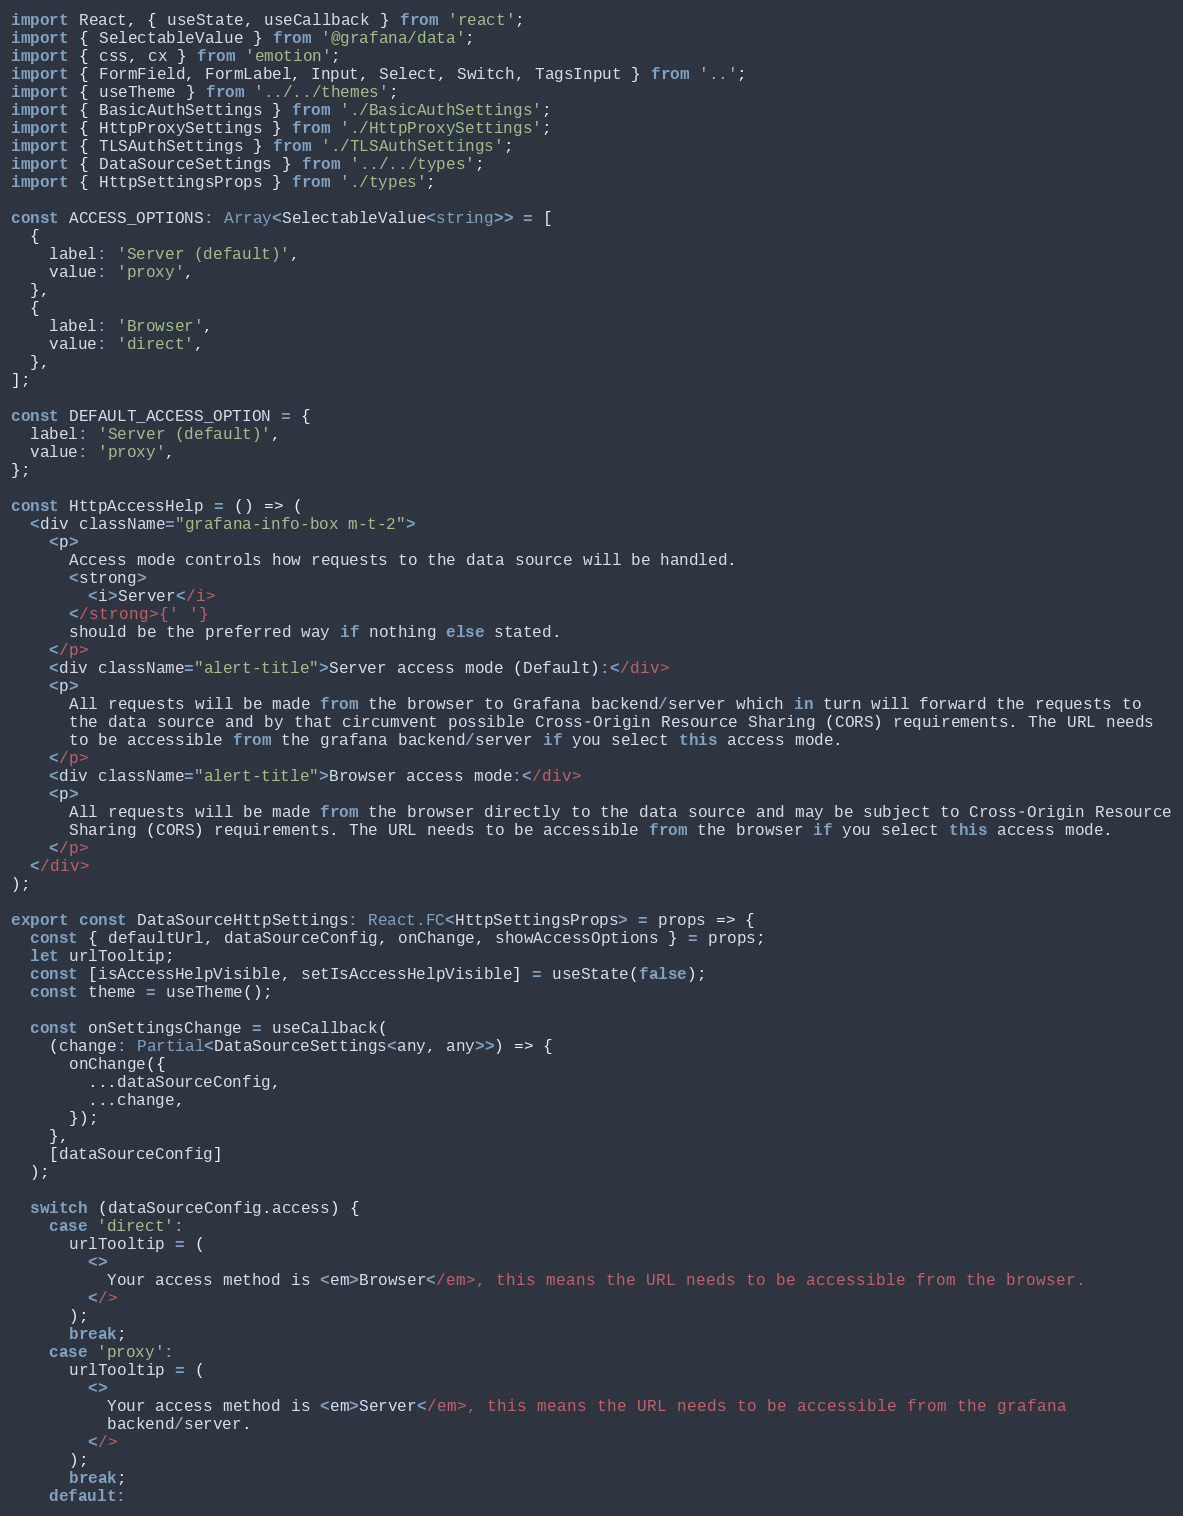<code> <loc_0><loc_0><loc_500><loc_500><_TypeScript_>import React, { useState, useCallback } from 'react';
import { SelectableValue } from '@grafana/data';
import { css, cx } from 'emotion';
import { FormField, FormLabel, Input, Select, Switch, TagsInput } from '..';
import { useTheme } from '../../themes';
import { BasicAuthSettings } from './BasicAuthSettings';
import { HttpProxySettings } from './HttpProxySettings';
import { TLSAuthSettings } from './TLSAuthSettings';
import { DataSourceSettings } from '../../types';
import { HttpSettingsProps } from './types';

const ACCESS_OPTIONS: Array<SelectableValue<string>> = [
  {
    label: 'Server (default)',
    value: 'proxy',
  },
  {
    label: 'Browser',
    value: 'direct',
  },
];

const DEFAULT_ACCESS_OPTION = {
  label: 'Server (default)',
  value: 'proxy',
};

const HttpAccessHelp = () => (
  <div className="grafana-info-box m-t-2">
    <p>
      Access mode controls how requests to the data source will be handled.
      <strong>
        <i>Server</i>
      </strong>{' '}
      should be the preferred way if nothing else stated.
    </p>
    <div className="alert-title">Server access mode (Default):</div>
    <p>
      All requests will be made from the browser to Grafana backend/server which in turn will forward the requests to
      the data source and by that circumvent possible Cross-Origin Resource Sharing (CORS) requirements. The URL needs
      to be accessible from the grafana backend/server if you select this access mode.
    </p>
    <div className="alert-title">Browser access mode:</div>
    <p>
      All requests will be made from the browser directly to the data source and may be subject to Cross-Origin Resource
      Sharing (CORS) requirements. The URL needs to be accessible from the browser if you select this access mode.
    </p>
  </div>
);

export const DataSourceHttpSettings: React.FC<HttpSettingsProps> = props => {
  const { defaultUrl, dataSourceConfig, onChange, showAccessOptions } = props;
  let urlTooltip;
  const [isAccessHelpVisible, setIsAccessHelpVisible] = useState(false);
  const theme = useTheme();

  const onSettingsChange = useCallback(
    (change: Partial<DataSourceSettings<any, any>>) => {
      onChange({
        ...dataSourceConfig,
        ...change,
      });
    },
    [dataSourceConfig]
  );

  switch (dataSourceConfig.access) {
    case 'direct':
      urlTooltip = (
        <>
          Your access method is <em>Browser</em>, this means the URL needs to be accessible from the browser.
        </>
      );
      break;
    case 'proxy':
      urlTooltip = (
        <>
          Your access method is <em>Server</em>, this means the URL needs to be accessible from the grafana
          backend/server.
        </>
      );
      break;
    default:</code> 